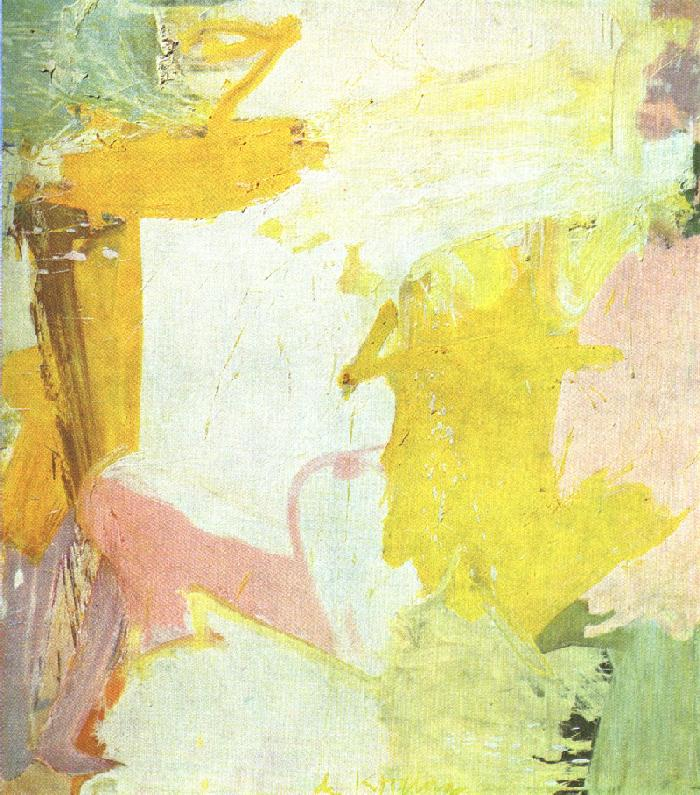What feelings or emotions does this abstract art evoke in you? This abstract piece evokes a sense of serenity and gentleness, primarily due to its pastel color palette. The flow of the brushstrokes gives it a feeling of fluidity and calm. The warm hues of yellow convey cheerfulness and warmth, while the soft pink adds a touch of tenderness. The entire composition feels like a gentle dance, inviting the viewer to a place of tranquility and introspection. Can you create a story based on the emotions drawn from this painting? Once upon a time, in a land painted with the hues of dawn, there lived a young artist named Elara. Every morning, she watched the sunrise, captivated by the gentle merge of pink and yellow as night gave way to day. Inspired by these serendipitous colors, she painted her emotions onto a blank canvas, creating a masterpiece that reflected her inner peace and joy. This painting became a magical portal, drawing those who gazed upon it into a serene world where they could find solace and reflection, just as Elara did every dawn. This world of colors and emotions became a sanctuary for lost souls, offering them a reminder of the beauty and tranquility that still existed in their lives. 